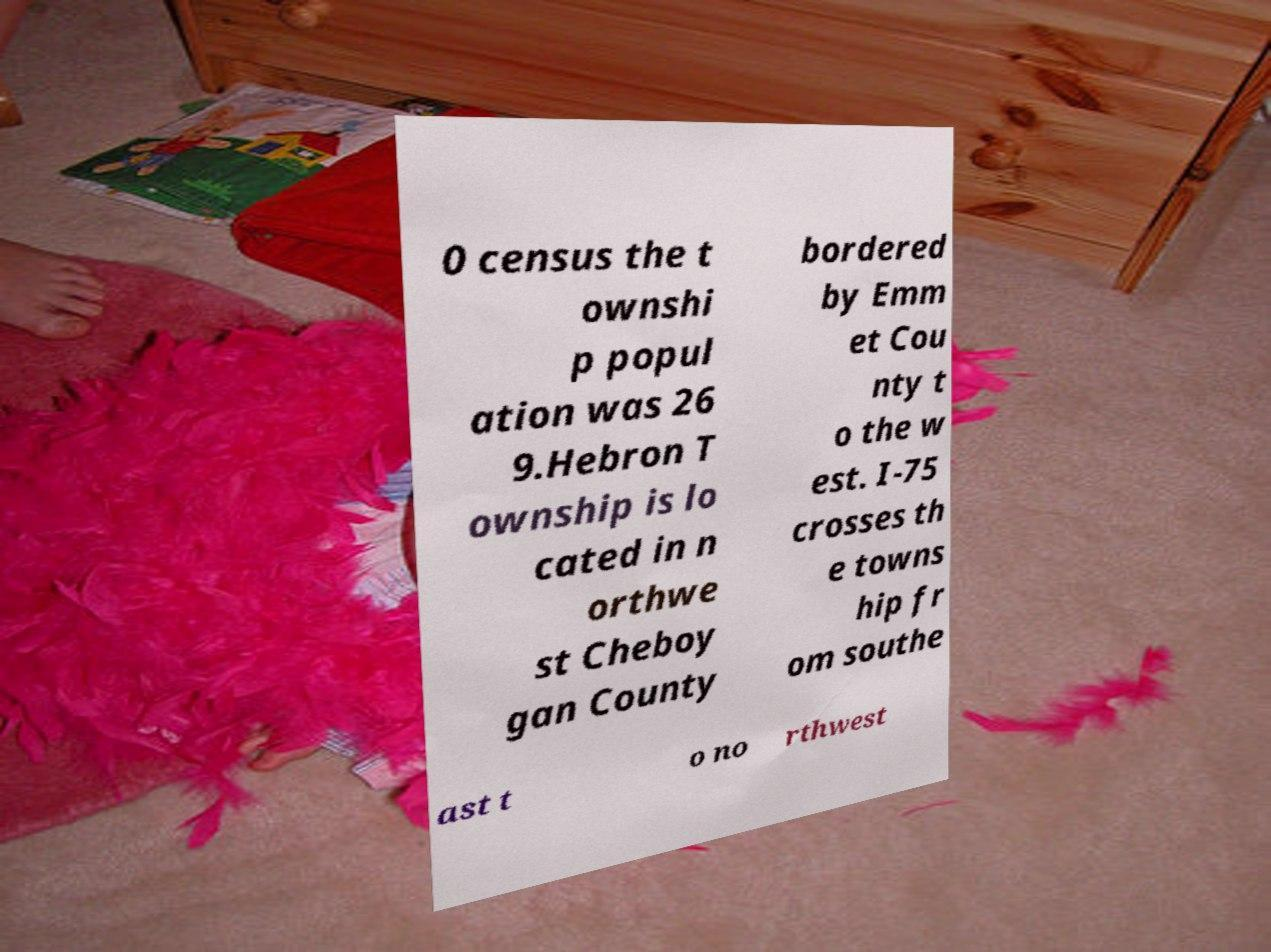Can you read and provide the text displayed in the image?This photo seems to have some interesting text. Can you extract and type it out for me? 0 census the t ownshi p popul ation was 26 9.Hebron T ownship is lo cated in n orthwe st Cheboy gan County bordered by Emm et Cou nty t o the w est. I-75 crosses th e towns hip fr om southe ast t o no rthwest 